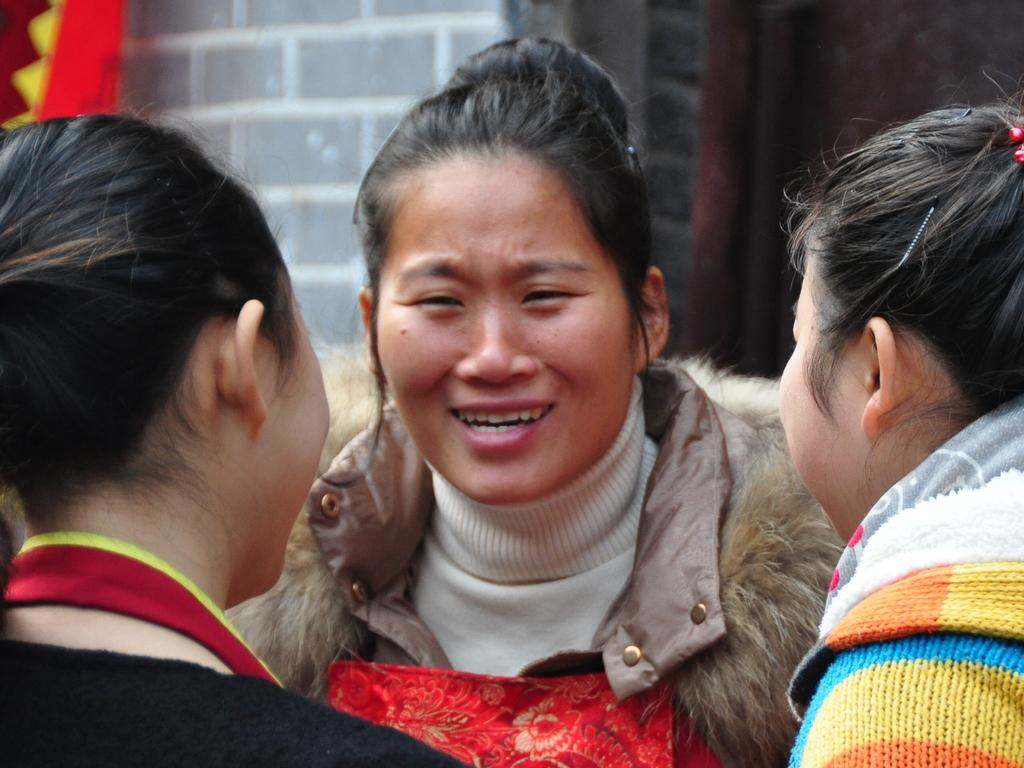How many people are in the image? There are three ladies in the center of the image. What can be seen in the background of the image? There is a wall in the background of the image. What color is the cloth visible in the image? There is a red color cloth in the image. Can you see any wings on the ladies in the image? No, there are no wings visible on the ladies in the image. What type of pear is being used as a prop in the image? There is no pear present in the image. 